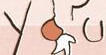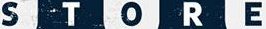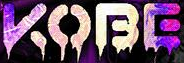What words are shown in these images in order, separated by a semicolon? you; STORE; KOBE 